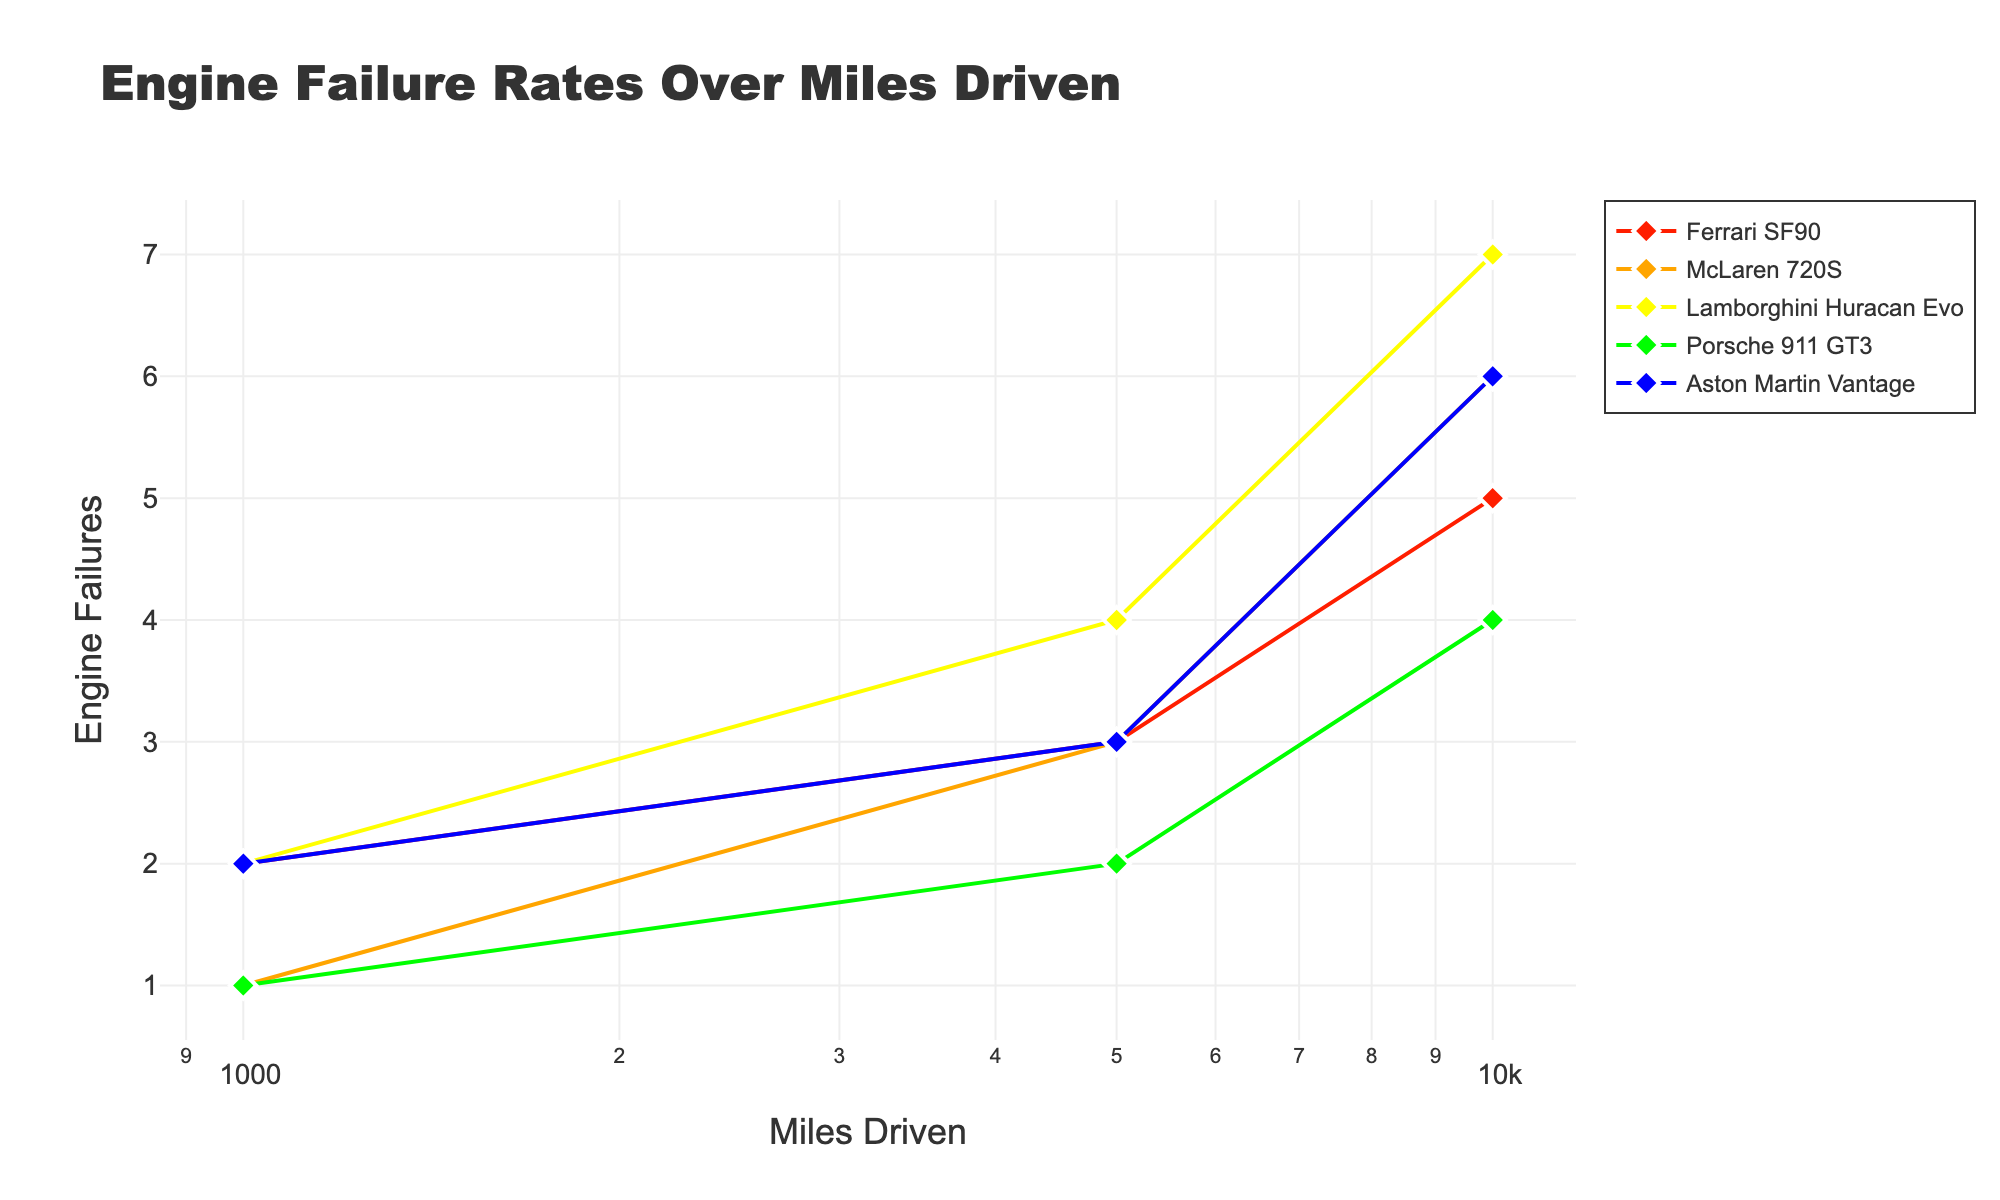How many car models are shown in the plot? The plot displays each car model's data in different colors and legends. By counting the distinct legends in the plot, we can determine the number of car models.
Answer: 5 What is the title of the plot? The title is prominently shown at the top of the plot, usually in large font to attract attention.
Answer: Engine Failure Rates Over Miles Driven Which car model has the fewest engine failures at 10000 miles driven? By looking at the data points for 10000 miles on the x-axis and identifying the car model with the lowest engine failure count on the y-axis, we can determine the car model with the fewest failures.
Answer: Porsche 911 GT3 What is the range of miles driven covered in the plot? The x-axis displays the range of miles driven, typically shown as tick marks. Identifying the smallest and largest values gives the range.
Answer: 1000 to 10000 For the Ferrari SF90, how much does the number of engine failures increase from 5000 to 10000 miles driven? By examining the engine failures count at 5000 and 10000 miles on the y-axis for the Ferrari SF90, then subtracting the lower value from the higher value, we can determine the increase.
Answer: 2 Which car model has the highest rate of engine failures increase from 1000 to 10000 miles driven? Calculate the rate of increase for each model by finding the difference in engine failures between 1000 and 10000 miles and dividing by the difference in miles (9000 miles). The model with the highest rate is the one with the largest result.
Answer: Lamborghini Huracan Evo How does the engine failure rate of McLaren 720S compare to the Ferrari SF90 at 5000 miles driven? By comparing the engine failure counts at 5000 miles for McLaren 720S and Ferrari SF90 on the y-axis, we can determine which has more or fewer failures at that specific driving distance.
Answer: Equal (both have 3 failures) What pattern does the engine failure rate show as miles driven increase for each car model? By looking at the trend lines for each car model, we can observe if the patterns suggest a steady increase, exponential growth, or other forms of patterns in engine failures over miles driven.
Answer: Increases steadily What can we infer about the reliability of the Porsche 911 GT3 over 10000 miles compared to the other models? Analyzing the trend line and final engine failure count for the Porsche 911 GT3 in comparison to other models' trends and counts helps in inferring its reliability.
Answer: More reliable (fewer failures) At which mileage do most car models start to show a steep increase in engine failures? Observing the plot, we look for the mileage point where the slope of the trend lines for most car models becomes steeper, indicating a rise in engine failure rates.
Answer: Around 5000 miles 